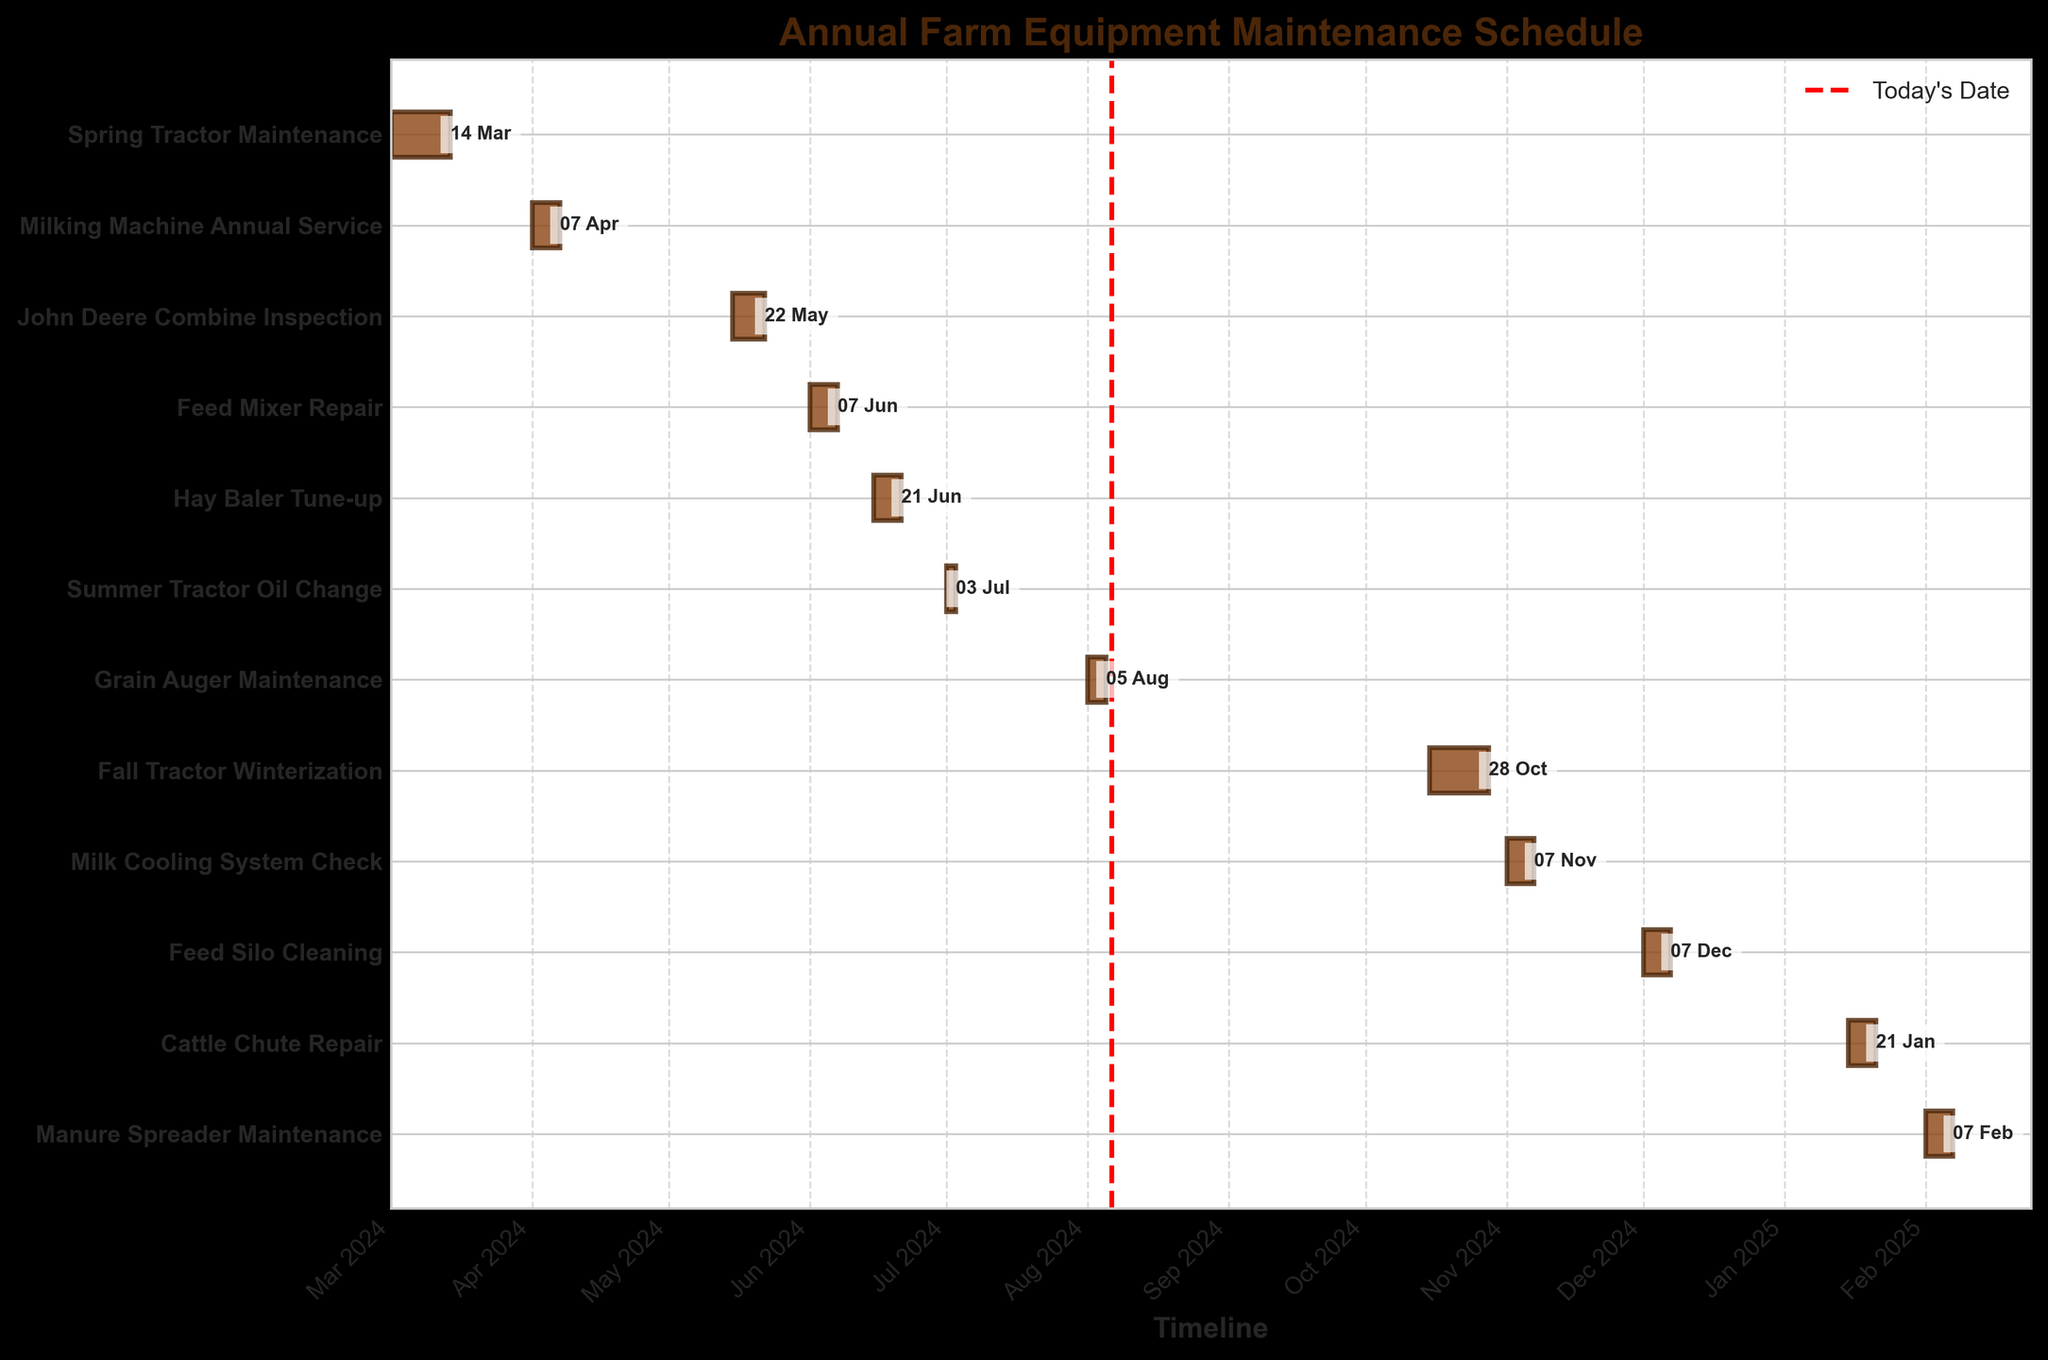What's the title of the chart? The title is usually displayed at the top of the chart and is useful to understand the focus of the data presented. This chart's title is "Annual Farm Equipment Maintenance Schedule" located at the top center.
Answer: Annual Farm Equipment Maintenance Schedule How long does the Spring Tractor Maintenance take? The duration of the Spring Tractor Maintenance can be determined by subtracting the start date (March 1, 2024) from the end date (March 14, 2024). The difference is 14 days.
Answer: 14 days Which maintenance task starts in May? By looking at the start dates on the horizontal axis and matching tasks on the vertical axis, the task that starts in May is the "John Deere Combine Inspection" starting on May 15, 2024.
Answer: John Deere Combine Inspection Compare the duration of Feed Mixer Repair and Hay Baler Tune-up. Which one lasts longer? The "Feed Mixer Repair" task duration is from June 1, 2024, to June 7, 2024, which is 7 days. The "Hay Baler Tune-up" duration is from June 15, 2024, to June 21, 2024, which is also 7 days. Both tasks last for the same amount of time.
Answer: Both last the same Which task has the shortest duration, and how long is it? To find the shortest task, we compare the durations of all tasks. The "Summer Tractor Oil Change" task is the shortest with a duration from July 1, 2024, to July 3, 2024, which is 3 days.
Answer: Summer Tractor Oil Change, 3 days How many maintenance tasks are scheduled before July 2024? By reviewing the start dates for all tasks, the tasks scheduled before July 2024 are: "Spring Tractor Maintenance," "Milking Machine Annual Service," "John Deere Combine Inspection," and "Feed Mixer Repair," totaling 4 tasks.
Answer: 4 tasks When does the Feed Silo Cleaning start and end? The Feed Silo Cleaning task starts on December 1, 2024, and ends on December 7, 2024, which is indicated by the horizontal bar’s position and length in the chart.
Answer: December 1, 2024, to December 7, 2024 Which task is scheduled to end last and on what date? By checking the end dates of all tasks in sequence, the "Manure Spreader Maintenance" task ends last on February 7, 2025.
Answer: Manure Spreader Maintenance, February 7, 2025 Are there more tasks scheduled in the first half or the second half of the year 2024? Count the tasks in each half of the year: 
- First half (Jan-Jun 2024): "Spring Tractor Maintenance," "Milking Machine Annual Service," "John Deere Combine Inspection," "Feed Mixer Repair" (4 tasks) 
- Second half (Jul-Dec 2024): "Summer Tractor Oil Change," "Grain Auger Maintenance," "Fall Tractor Winterization," "Milk Cooling System Check," "Feed Silo Cleaning" (5 tasks)
More tasks are scheduled in the second half.
Answer: Second half of 2024 